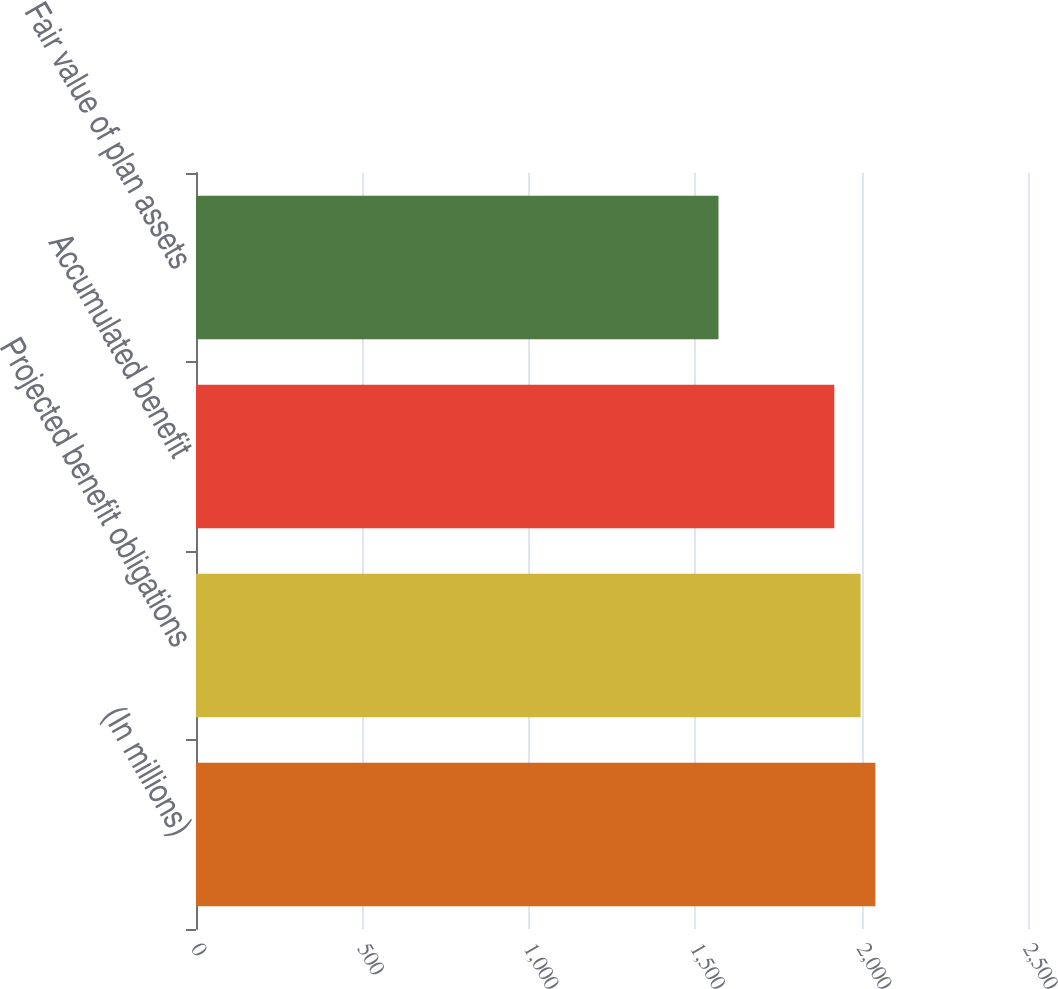Convert chart. <chart><loc_0><loc_0><loc_500><loc_500><bar_chart><fcel>(In millions)<fcel>Projected benefit obligations<fcel>Accumulated benefit<fcel>Fair value of plan assets<nl><fcel>2041.5<fcel>1997<fcel>1918<fcel>1570<nl></chart> 